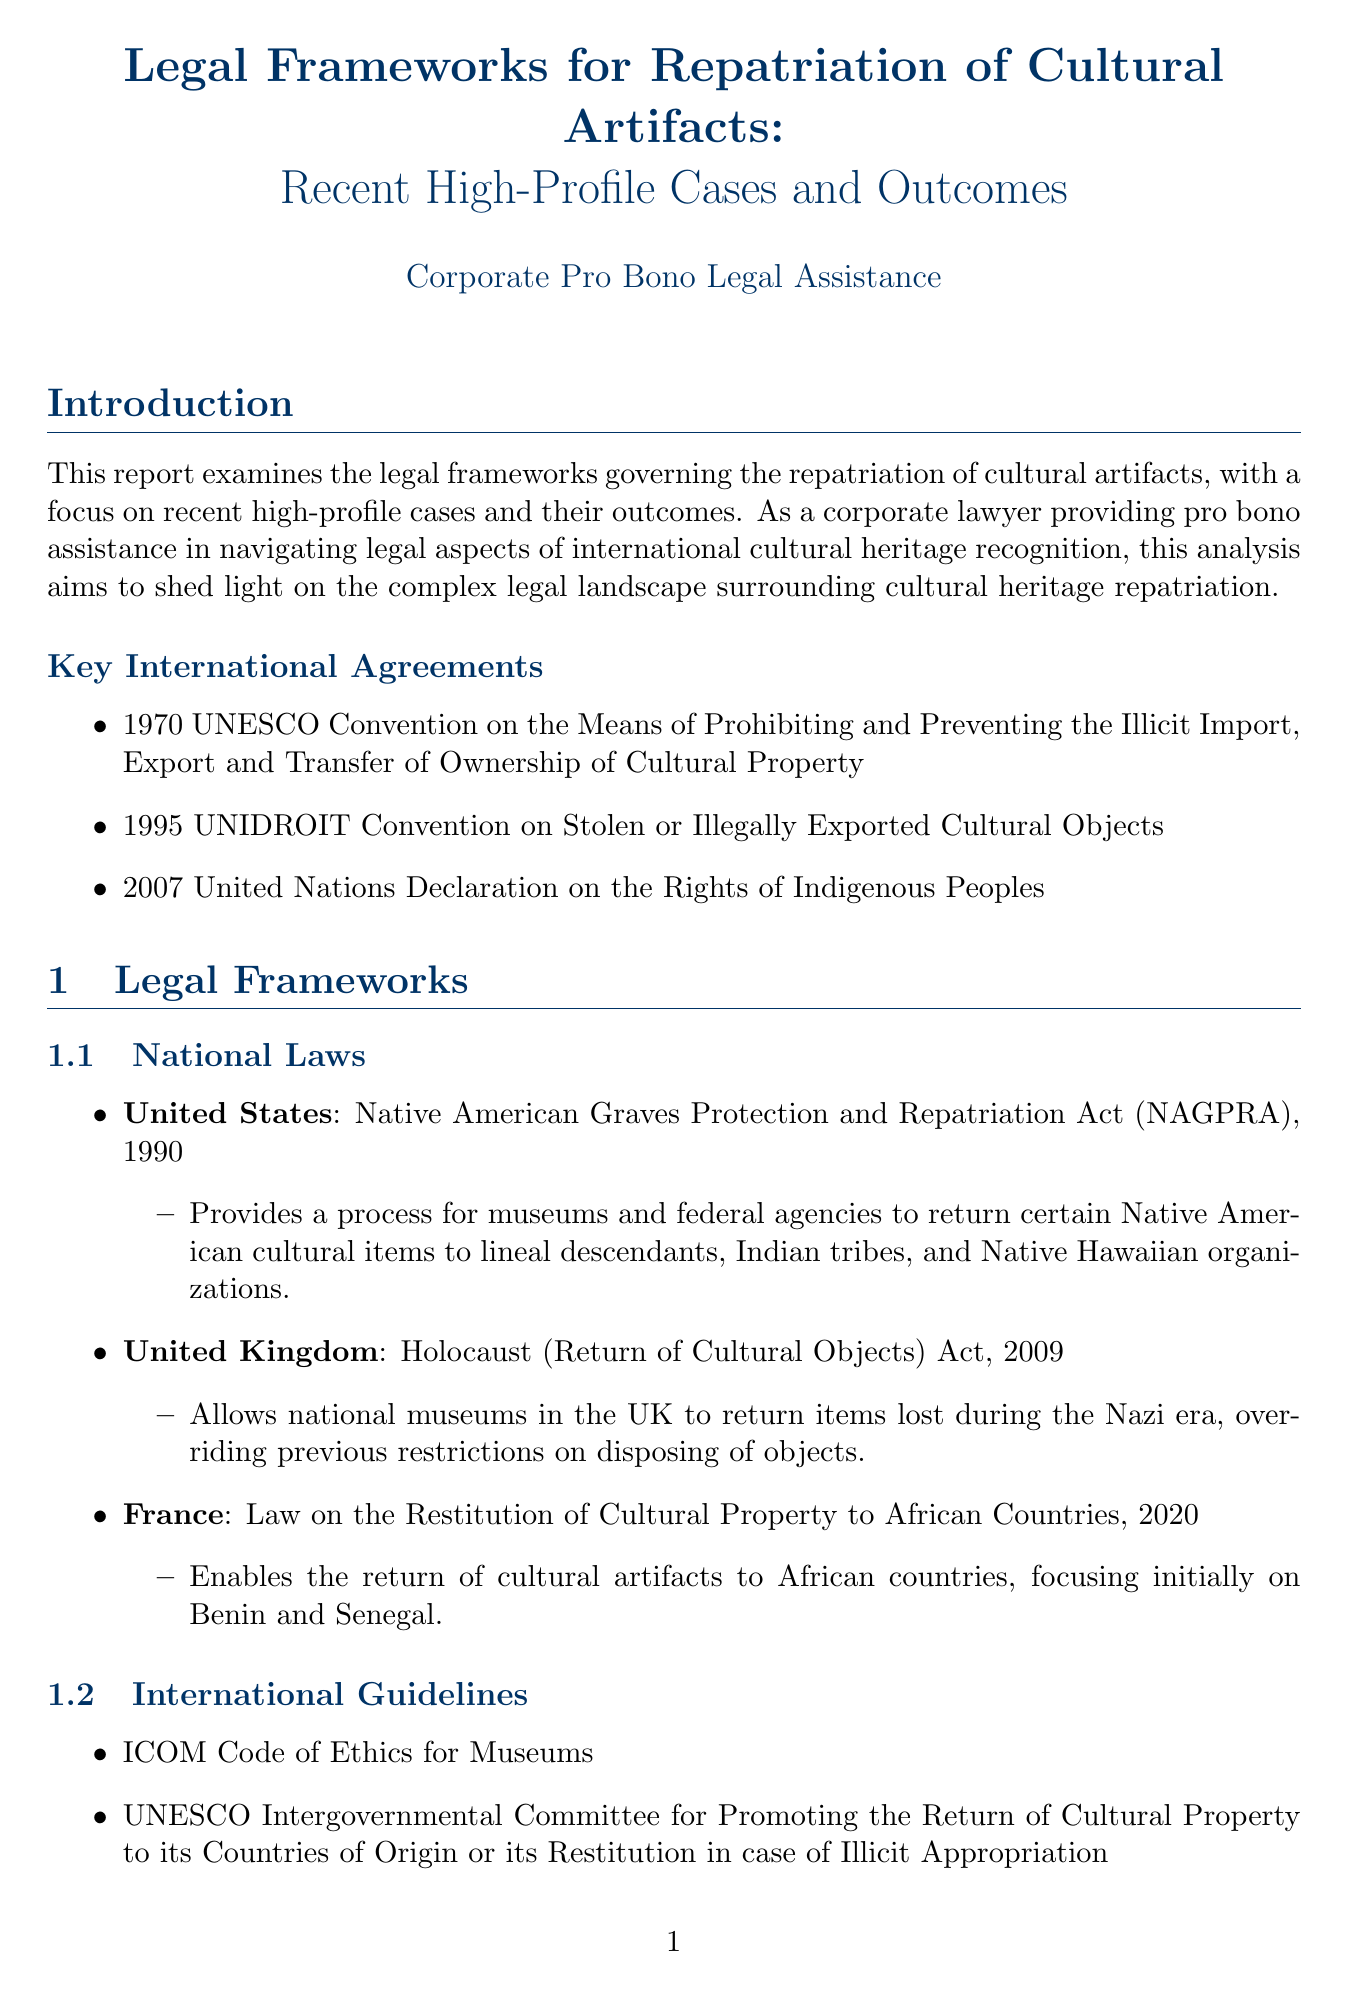What is the title of the report? The title of the report is prominently mentioned at the beginning of the document.
Answer: Legal Frameworks for Repatriation of Cultural Artifacts: Recent High-Profile Cases and Outcomes What year was the Native American Graves Protection and Repatriation Act enacted? The year of enactment for the Native American Graves Protection and Repatriation Act is listed under national laws.
Answer: 1990 Which country claimed the Benin Bronzes? The claimant for the Benin Bronzes is specified in the recent high-profile cases section.
Answer: Nigeria What legal implication arose from the Benin Bronzes repatriation case? The document provides insights into the legal implications of the Benin Bronzes case in relation to international agreements.
Answer: Highlighted the need for more comprehensive international agreements on cultural property repatriation What is one recommendation provided in the report? The report lists several recommendations at the end, which are specific actionable suggestions.
Answer: Strengthen international cooperation and harmonize legal frameworks What are the Parthenon Marbles? The Parthenon Marbles are described in the document and are related to a significant cultural dispute.
Answer: Ancient Greek sculptures from the Parthenon How many international agreements are mentioned in the introduction? The introduction specifies the number of key international agreements relevant to the repatriation of cultural artifacts.
Answer: Three 